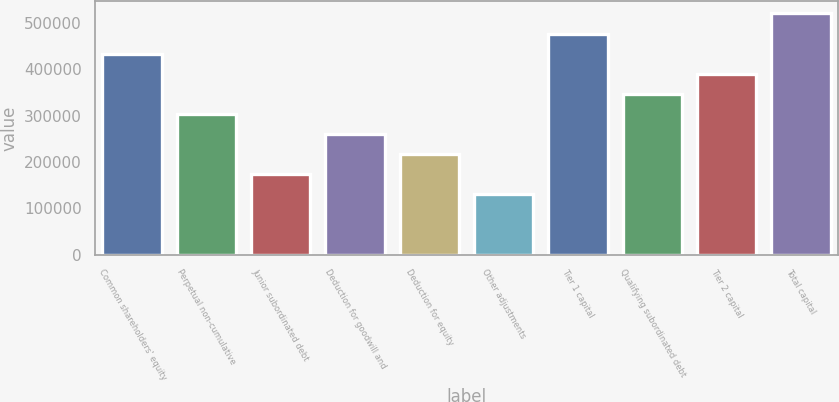Convert chart. <chart><loc_0><loc_0><loc_500><loc_500><bar_chart><fcel>Common shareholders' equity<fcel>Perpetual non-cumulative<fcel>Junior subordinated debt<fcel>Deduction for goodwill and<fcel>Deduction for equity<fcel>Other adjustments<fcel>Tier 1 capital<fcel>Qualifying subordinated debt<fcel>Tier 2 capital<fcel>Total capital<nl><fcel>433226<fcel>303261<fcel>173295<fcel>259939<fcel>216617<fcel>129973<fcel>476548<fcel>346582<fcel>389904<fcel>519870<nl></chart> 